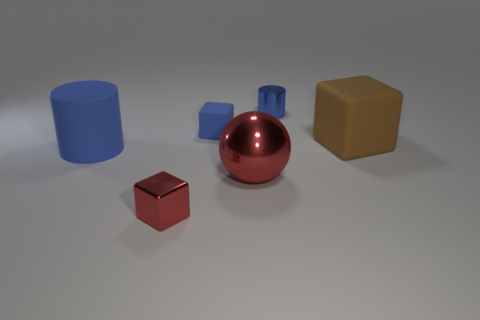Add 3 large red shiny spheres. How many objects exist? 9 Subtract all balls. How many objects are left? 5 Subtract 1 blocks. How many blocks are left? 2 Add 6 red balls. How many red balls are left? 7 Add 5 small cyan matte objects. How many small cyan matte objects exist? 5 Subtract all rubber cubes. How many cubes are left? 1 Subtract 0 brown cylinders. How many objects are left? 6 Subtract all green balls. Subtract all blue blocks. How many balls are left? 1 Subtract all gray cubes. How many gray spheres are left? 0 Subtract all big brown matte blocks. Subtract all big red balls. How many objects are left? 4 